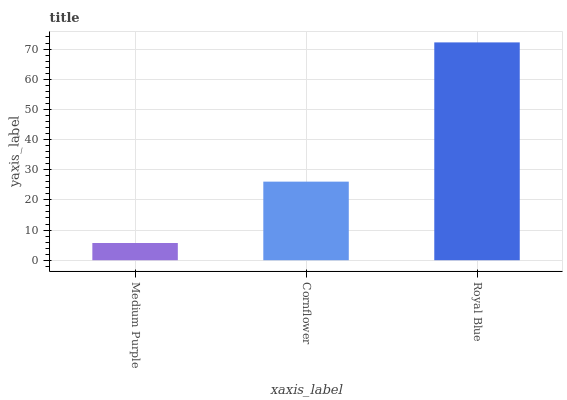Is Medium Purple the minimum?
Answer yes or no. Yes. Is Royal Blue the maximum?
Answer yes or no. Yes. Is Cornflower the minimum?
Answer yes or no. No. Is Cornflower the maximum?
Answer yes or no. No. Is Cornflower greater than Medium Purple?
Answer yes or no. Yes. Is Medium Purple less than Cornflower?
Answer yes or no. Yes. Is Medium Purple greater than Cornflower?
Answer yes or no. No. Is Cornflower less than Medium Purple?
Answer yes or no. No. Is Cornflower the high median?
Answer yes or no. Yes. Is Cornflower the low median?
Answer yes or no. Yes. Is Royal Blue the high median?
Answer yes or no. No. Is Royal Blue the low median?
Answer yes or no. No. 